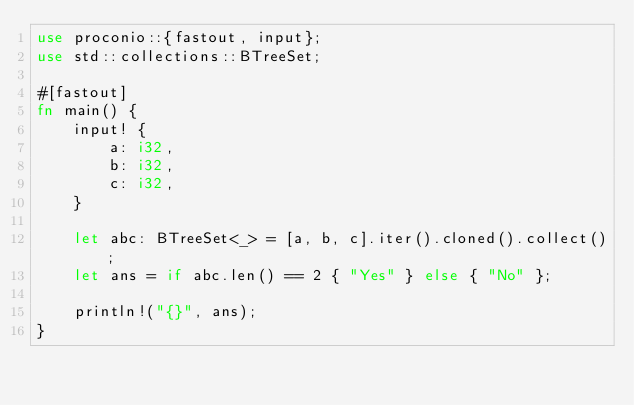Convert code to text. <code><loc_0><loc_0><loc_500><loc_500><_Rust_>use proconio::{fastout, input};
use std::collections::BTreeSet;

#[fastout]
fn main() {
    input! {
        a: i32,
        b: i32,
        c: i32,
    }

    let abc: BTreeSet<_> = [a, b, c].iter().cloned().collect();
    let ans = if abc.len() == 2 { "Yes" } else { "No" };

    println!("{}", ans);
}
</code> 